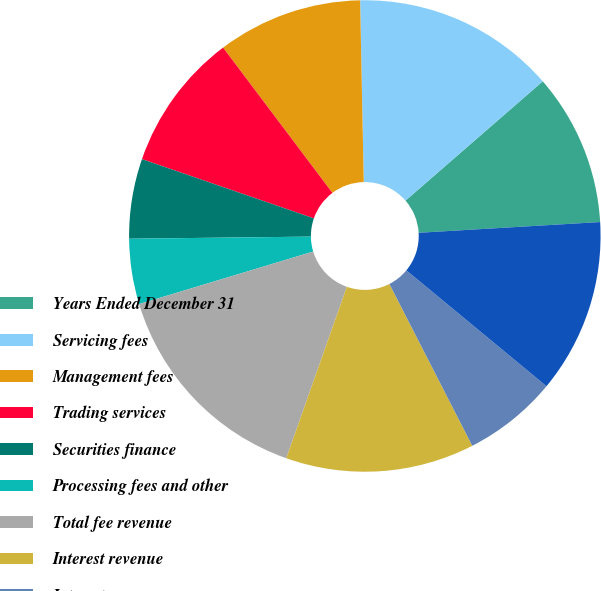<chart> <loc_0><loc_0><loc_500><loc_500><pie_chart><fcel>Years Ended December 31<fcel>Servicing fees<fcel>Management fees<fcel>Trading services<fcel>Securities finance<fcel>Processing fees and other<fcel>Total fee revenue<fcel>Interest revenue<fcel>Interest expense<fcel>Net interest revenue<nl><fcel>10.45%<fcel>13.93%<fcel>9.95%<fcel>9.45%<fcel>5.47%<fcel>4.48%<fcel>14.93%<fcel>12.94%<fcel>6.47%<fcel>11.94%<nl></chart> 